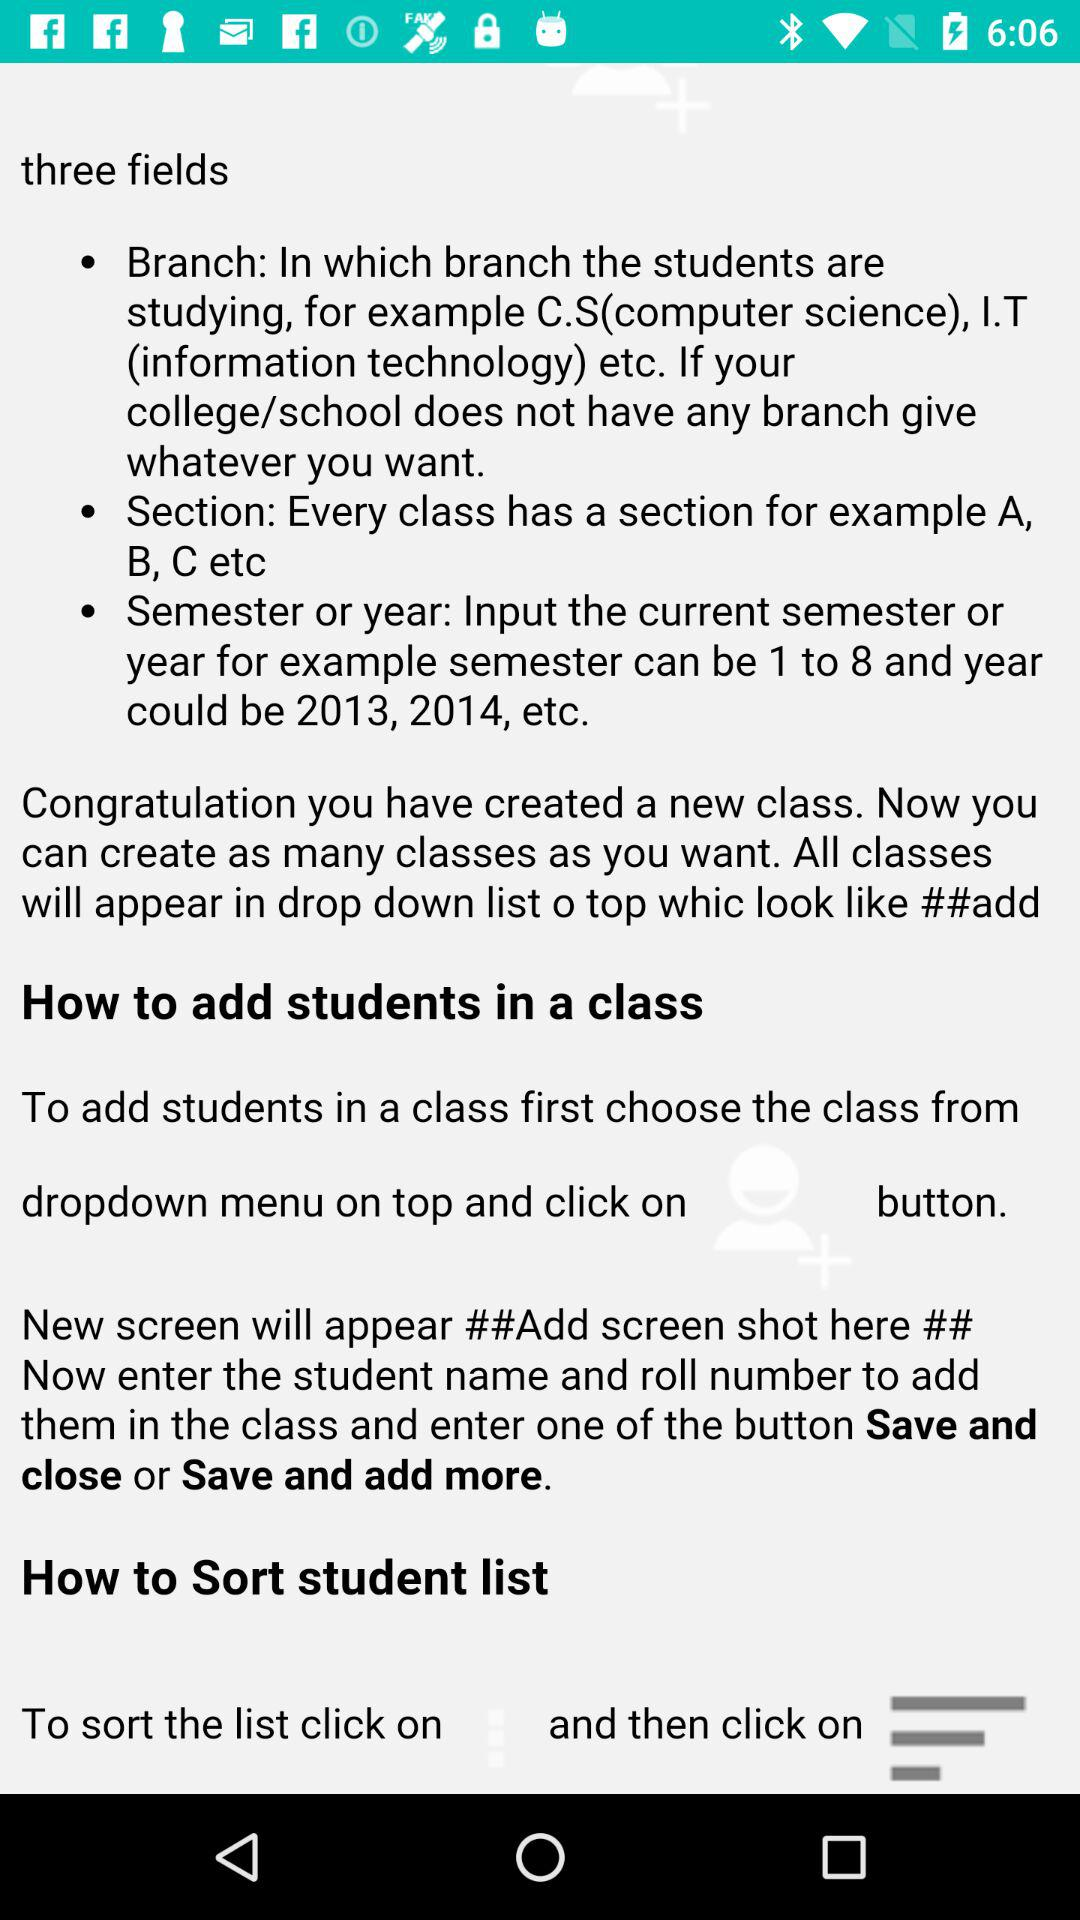How many fields are there to create a class?
Answer the question using a single word or phrase. 3 